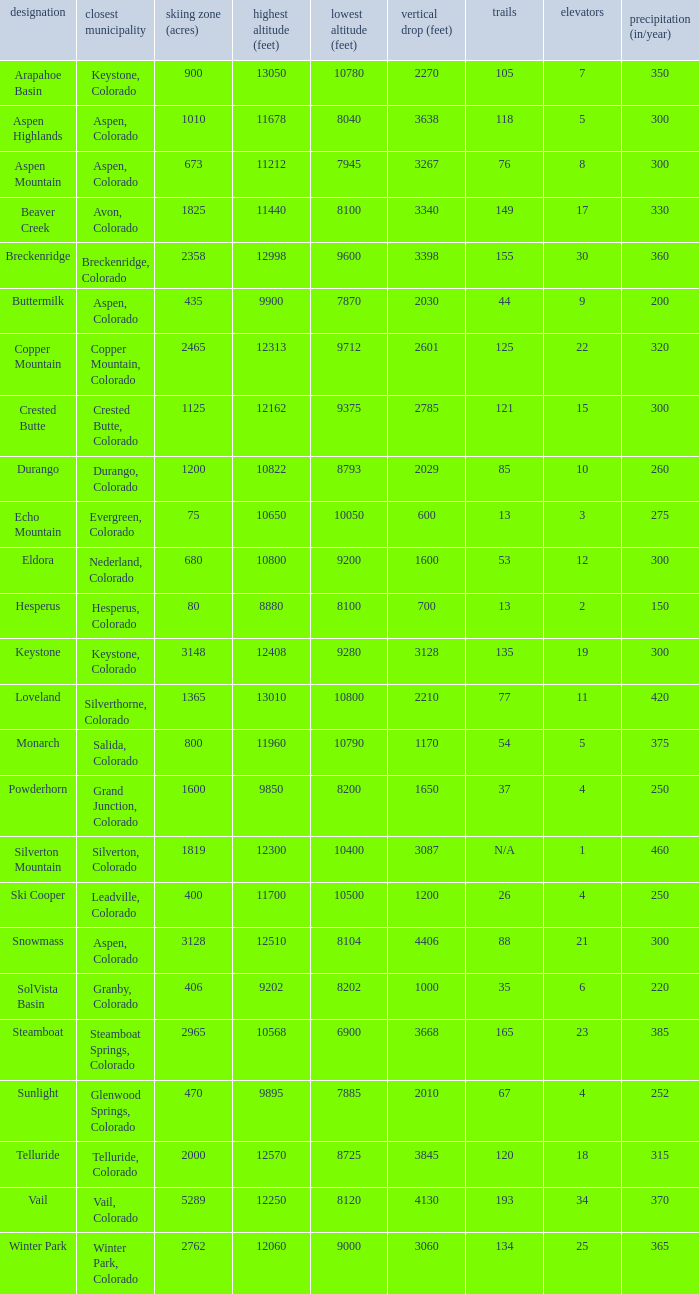How many resorts have 118 runs? 1.0. 